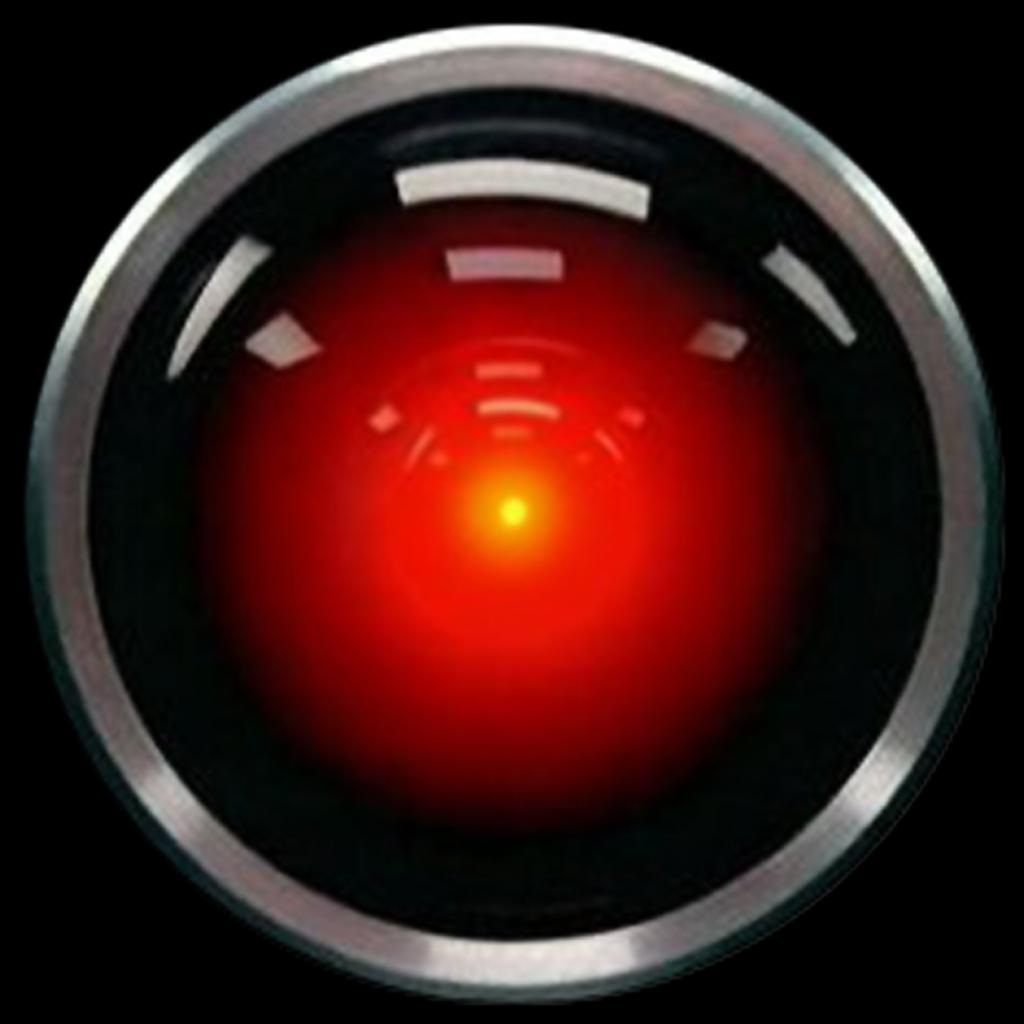What type of lens is visible in the image? There is a Hal lens in the image. What colors can be seen in the image? The image features yellow, red, and black colors. How would you describe the lighting in the image? The corners of the image are dark. How do the giants in the image create noise? There are no giants present in the image, so it is not possible to determine how they might create noise. 